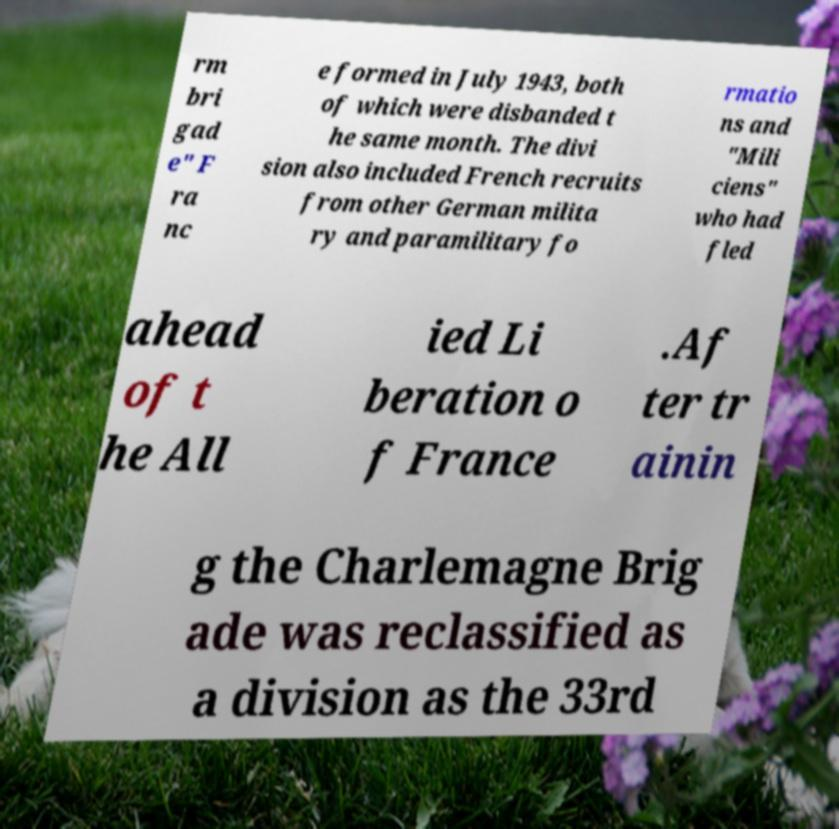Can you accurately transcribe the text from the provided image for me? rm bri gad e" F ra nc e formed in July 1943, both of which were disbanded t he same month. The divi sion also included French recruits from other German milita ry and paramilitary fo rmatio ns and "Mili ciens" who had fled ahead of t he All ied Li beration o f France .Af ter tr ainin g the Charlemagne Brig ade was reclassified as a division as the 33rd 